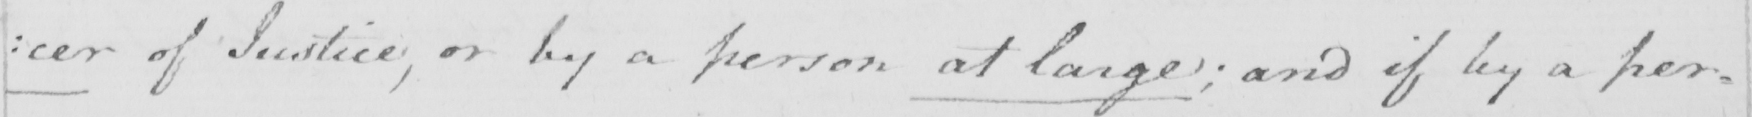Can you read and transcribe this handwriting? : cer of Justice , or by a person at large ; and if by a per- 